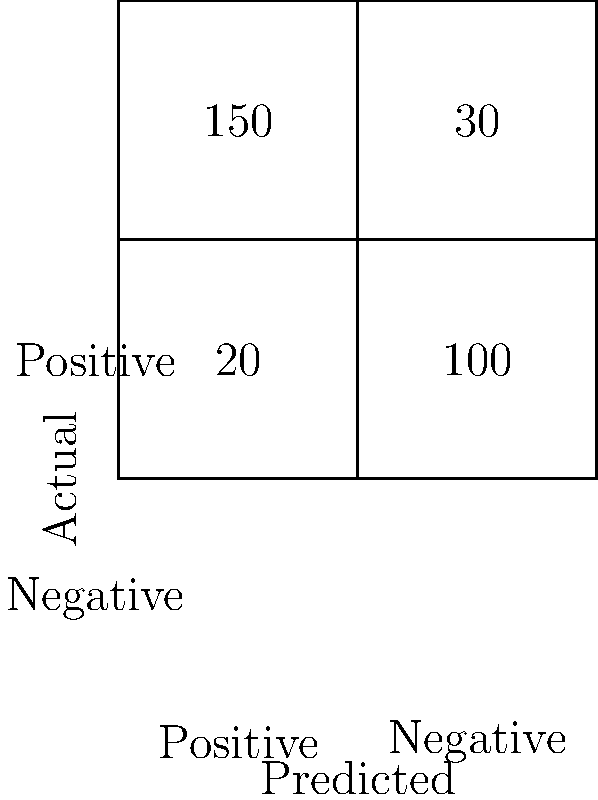Given the confusion matrix for a sentiment analysis model shown above, calculate the model's precision for positive sentiment. Round your answer to two decimal places. To calculate the precision for positive sentiment, we need to follow these steps:

1. Identify the components of the confusion matrix:
   - True Positives (TP): 150 (correctly predicted positive)
   - False Positives (FP): 30 (incorrectly predicted positive)
   - False Negatives (FN): 20 (incorrectly predicted negative)
   - True Negatives (TN): 100 (correctly predicted negative)

2. Recall the formula for precision:
   $$ \text{Precision} = \frac{\text{True Positives}}{\text{True Positives} + \text{False Positives}} $$

3. Substitute the values:
   $$ \text{Precision} = \frac{150}{150 + 30} = \frac{150}{180} $$

4. Perform the division:
   $$ \text{Precision} \approx 0.8333333 $$

5. Round to two decimal places:
   $$ \text{Precision} \approx 0.83 $$

Therefore, the precision for positive sentiment is approximately 0.83 or 83%.
Answer: 0.83 